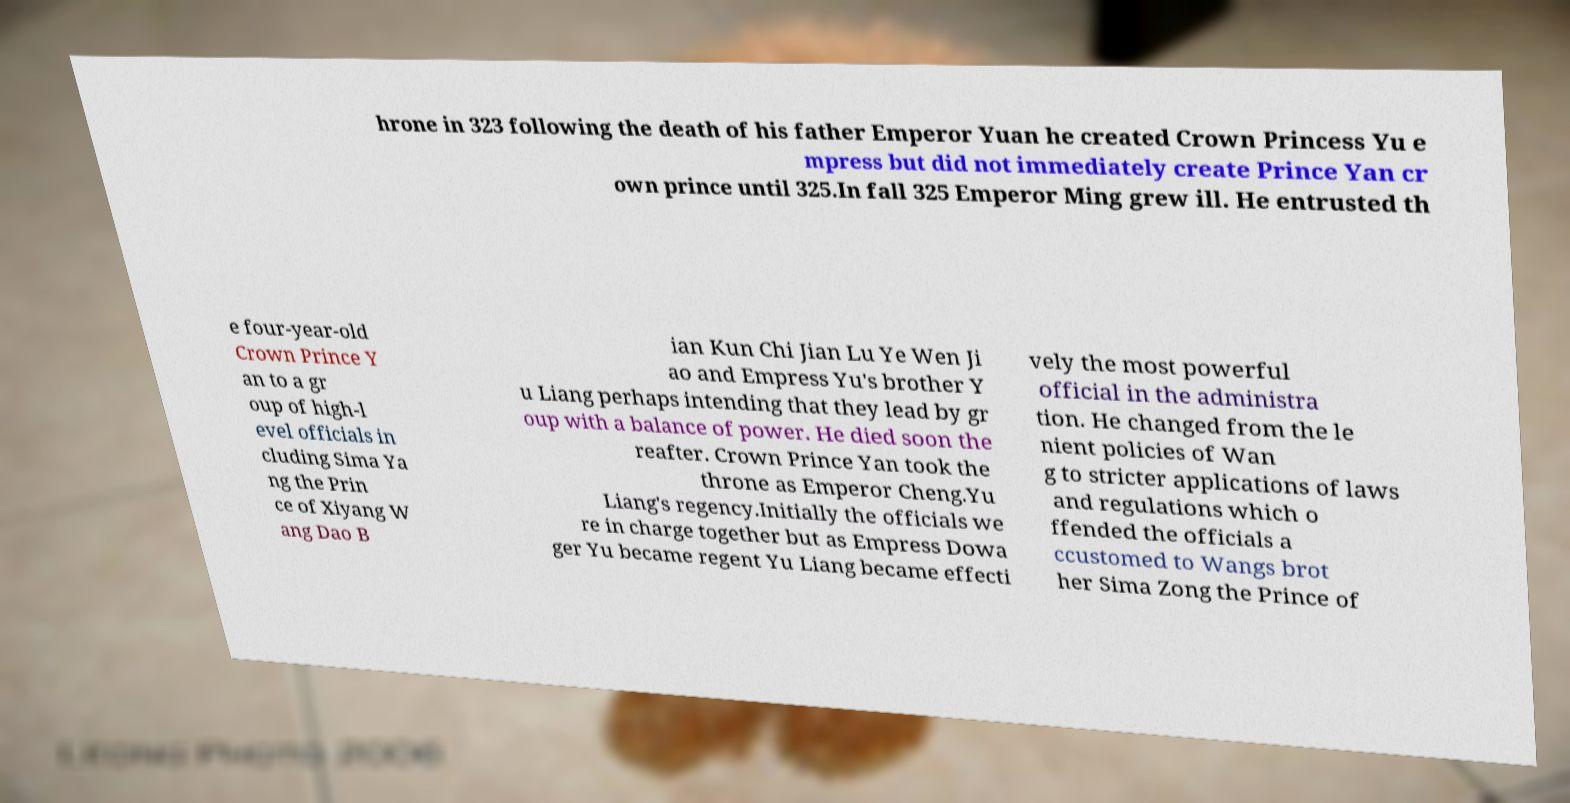There's text embedded in this image that I need extracted. Can you transcribe it verbatim? hrone in 323 following the death of his father Emperor Yuan he created Crown Princess Yu e mpress but did not immediately create Prince Yan cr own prince until 325.In fall 325 Emperor Ming grew ill. He entrusted th e four-year-old Crown Prince Y an to a gr oup of high-l evel officials in cluding Sima Ya ng the Prin ce of Xiyang W ang Dao B ian Kun Chi Jian Lu Ye Wen Ji ao and Empress Yu's brother Y u Liang perhaps intending that they lead by gr oup with a balance of power. He died soon the reafter. Crown Prince Yan took the throne as Emperor Cheng.Yu Liang's regency.Initially the officials we re in charge together but as Empress Dowa ger Yu became regent Yu Liang became effecti vely the most powerful official in the administra tion. He changed from the le nient policies of Wan g to stricter applications of laws and regulations which o ffended the officials a ccustomed to Wangs brot her Sima Zong the Prince of 